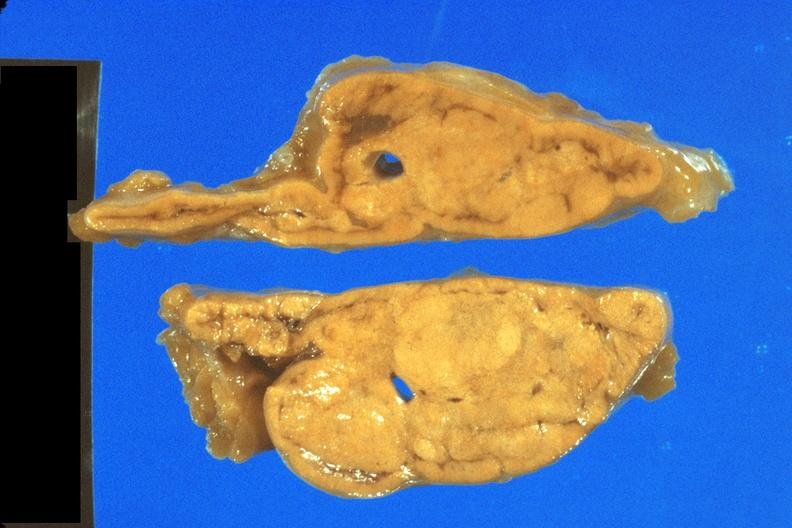s an opened peritoneal cavity cause by fibrous band strangulation present?
Answer the question using a single word or phrase. No 